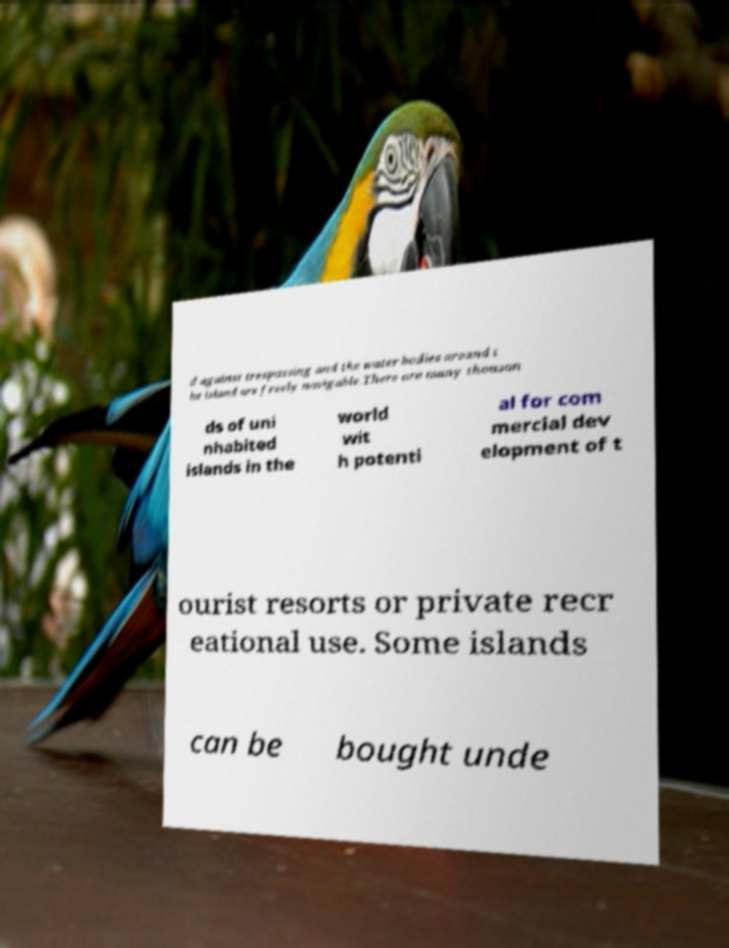Please identify and transcribe the text found in this image. d against trespassing and the water bodies around t he island are freely navigable.There are many thousan ds of uni nhabited islands in the world wit h potenti al for com mercial dev elopment of t ourist resorts or private recr eational use. Some islands can be bought unde 